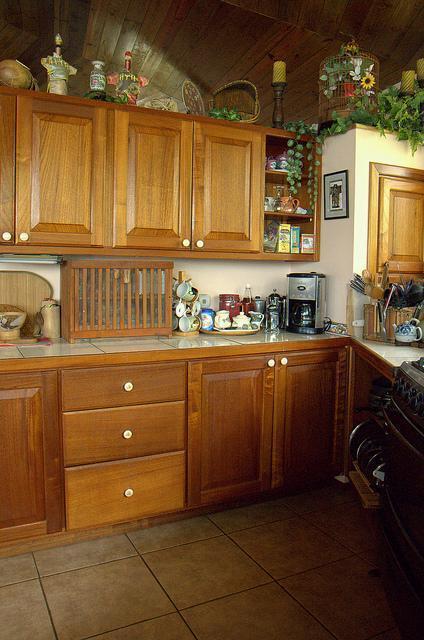How many drawers are in the bottom cabinet of this kitchen?
Pick the right solution, then justify: 'Answer: answer
Rationale: rationale.'
Options: Four, two, one, three. Answer: three.
Rationale: There are 3 door knobs. 